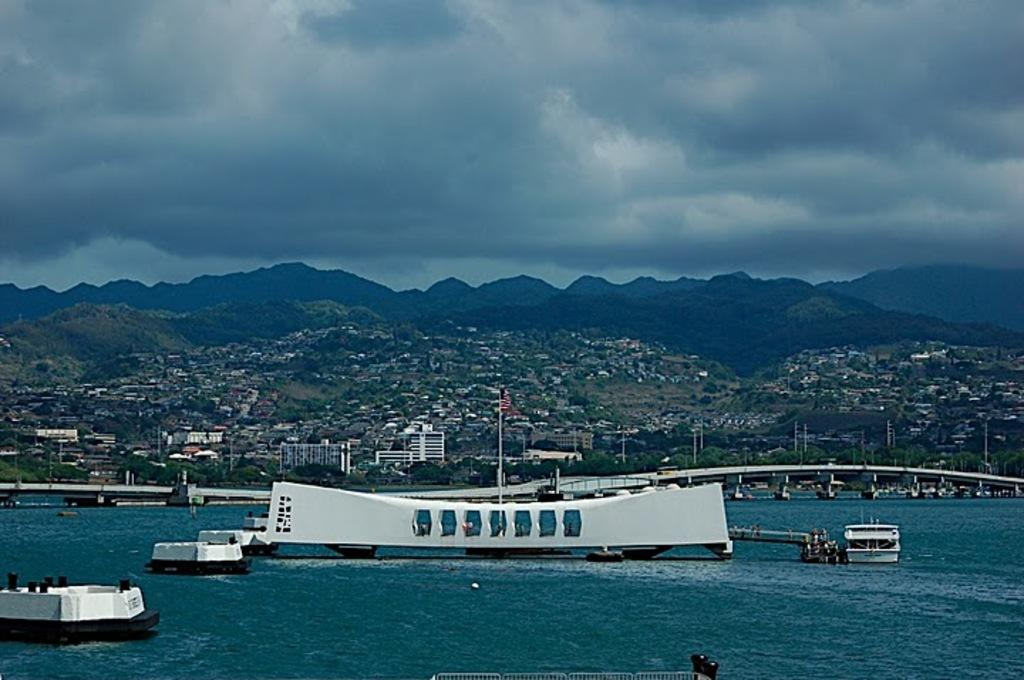What is at the bottom of the image? There is water at the bottom of the image. What is floating on the water? There are boats on the water. What can be seen in the distance in the image? There are hills, buildings, and poles in the background of the image. What is visible above the background elements? The sky is visible in the background of the image. What is the price of the form in the image? There is no form present in the image, so it is not possible to determine its price. 